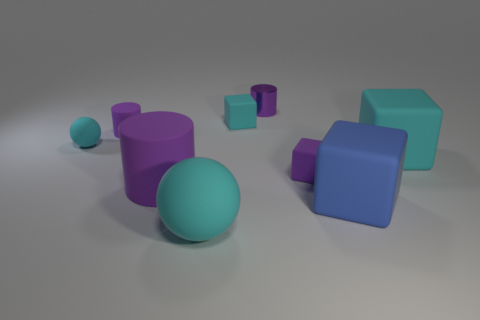The big blue rubber object is what shape?
Provide a short and direct response. Cube. There is a cylinder that is the same size as the purple shiny thing; what is its material?
Keep it short and to the point. Rubber. How many things are large gray shiny cubes or purple objects to the left of the large purple cylinder?
Offer a terse response. 1. What is the size of the other cyan ball that is made of the same material as the big cyan ball?
Offer a very short reply. Small. There is a big cyan object on the left side of the large block that is behind the tiny purple cube; what shape is it?
Your response must be concise. Sphere. There is a purple object that is both to the right of the large cylinder and in front of the purple metal cylinder; how big is it?
Provide a short and direct response. Small. Is there a cyan rubber object that has the same shape as the large blue thing?
Your response must be concise. Yes. Is there anything else that is the same shape as the big purple rubber thing?
Your answer should be compact. Yes. What material is the small cube that is behind the purple matte thing to the right of the block that is behind the tiny purple rubber cylinder?
Your response must be concise. Rubber. Are there any cyan blocks of the same size as the metallic object?
Make the answer very short. Yes. 